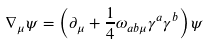Convert formula to latex. <formula><loc_0><loc_0><loc_500><loc_500>\nabla _ { \mu } \psi = \left ( \partial _ { \mu } + \frac { 1 } { 4 } \omega _ { a b \mu } \gamma ^ { a } \gamma ^ { b } \right ) \psi</formula> 